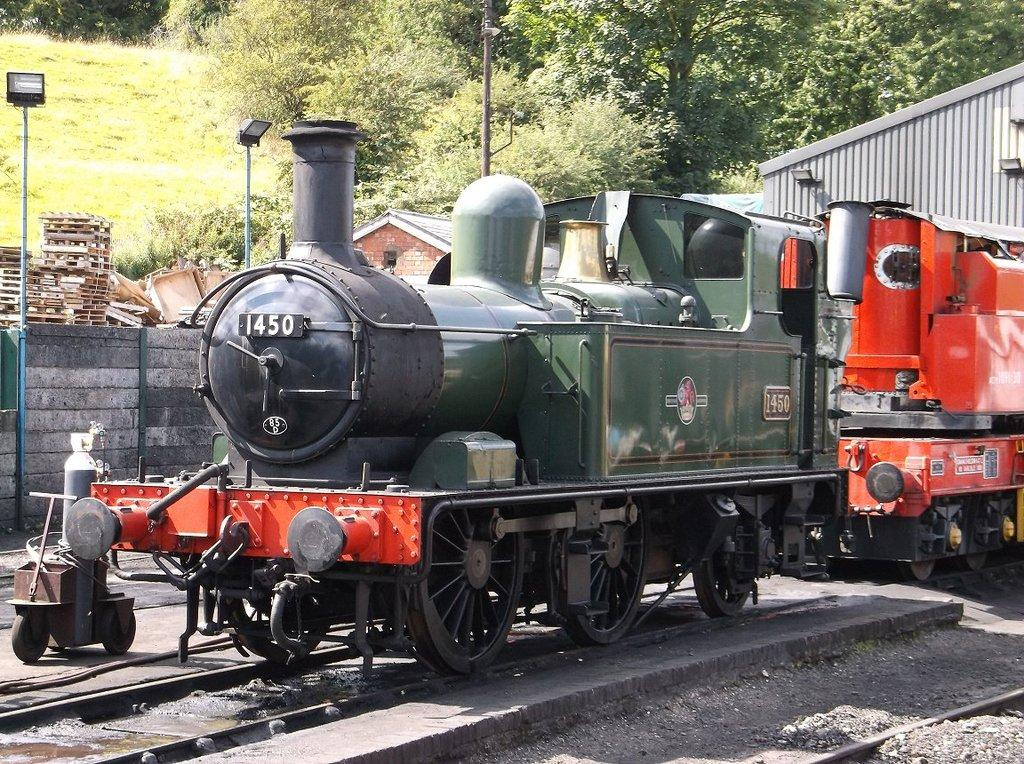<image>
Write a terse but informative summary of the picture. the old train 1450 is sitting on the track, likely for a tour 